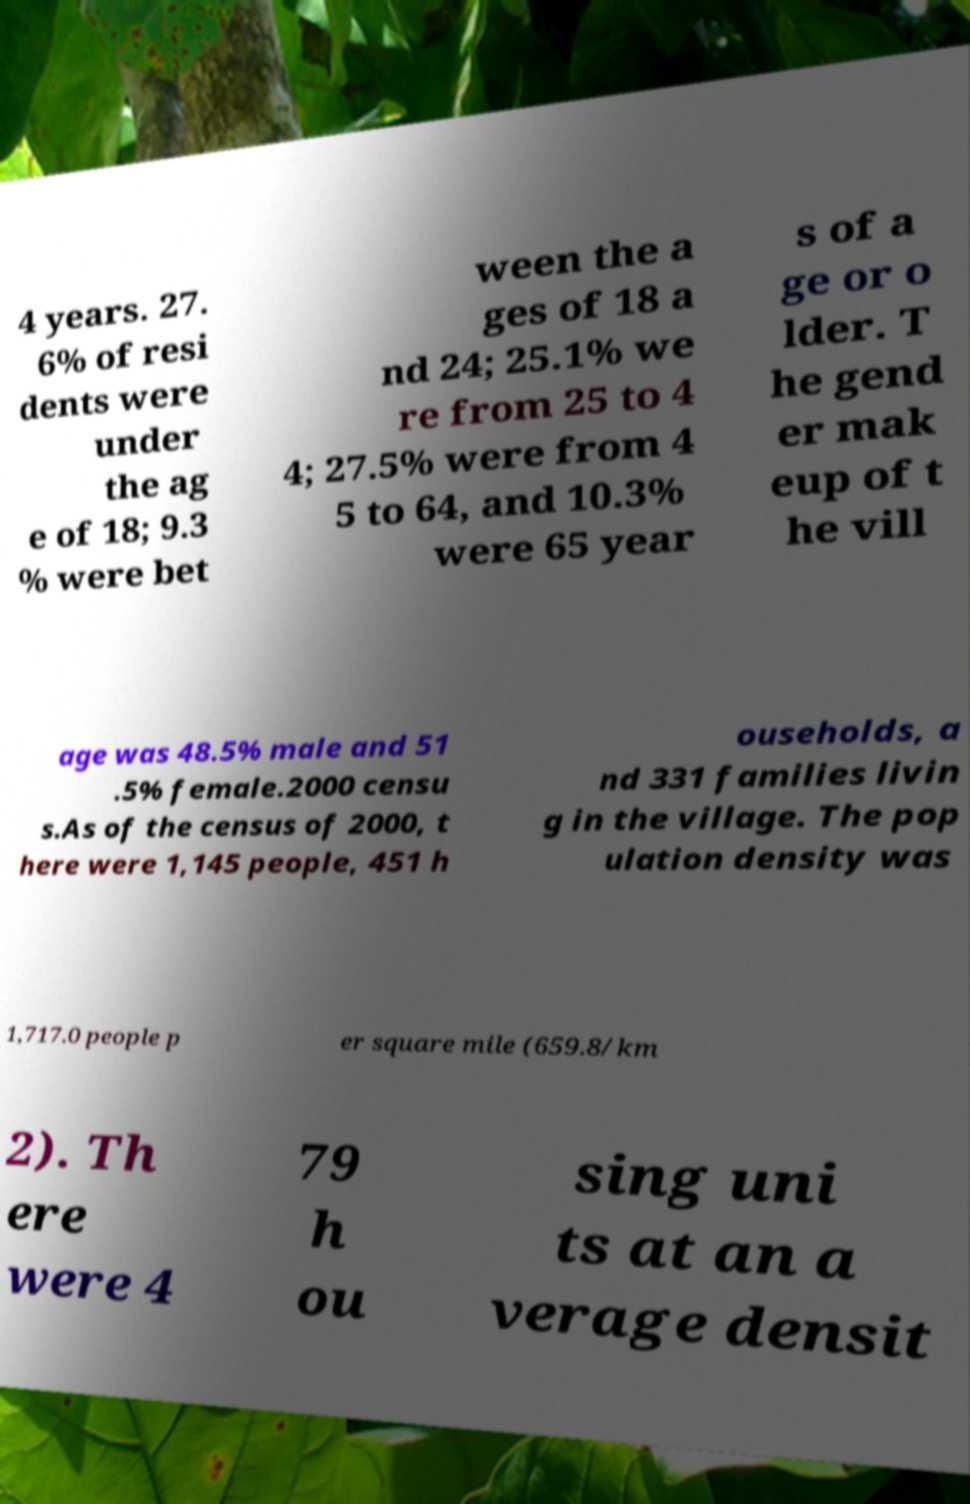For documentation purposes, I need the text within this image transcribed. Could you provide that? 4 years. 27. 6% of resi dents were under the ag e of 18; 9.3 % were bet ween the a ges of 18 a nd 24; 25.1% we re from 25 to 4 4; 27.5% were from 4 5 to 64, and 10.3% were 65 year s of a ge or o lder. T he gend er mak eup of t he vill age was 48.5% male and 51 .5% female.2000 censu s.As of the census of 2000, t here were 1,145 people, 451 h ouseholds, a nd 331 families livin g in the village. The pop ulation density was 1,717.0 people p er square mile (659.8/km 2). Th ere were 4 79 h ou sing uni ts at an a verage densit 